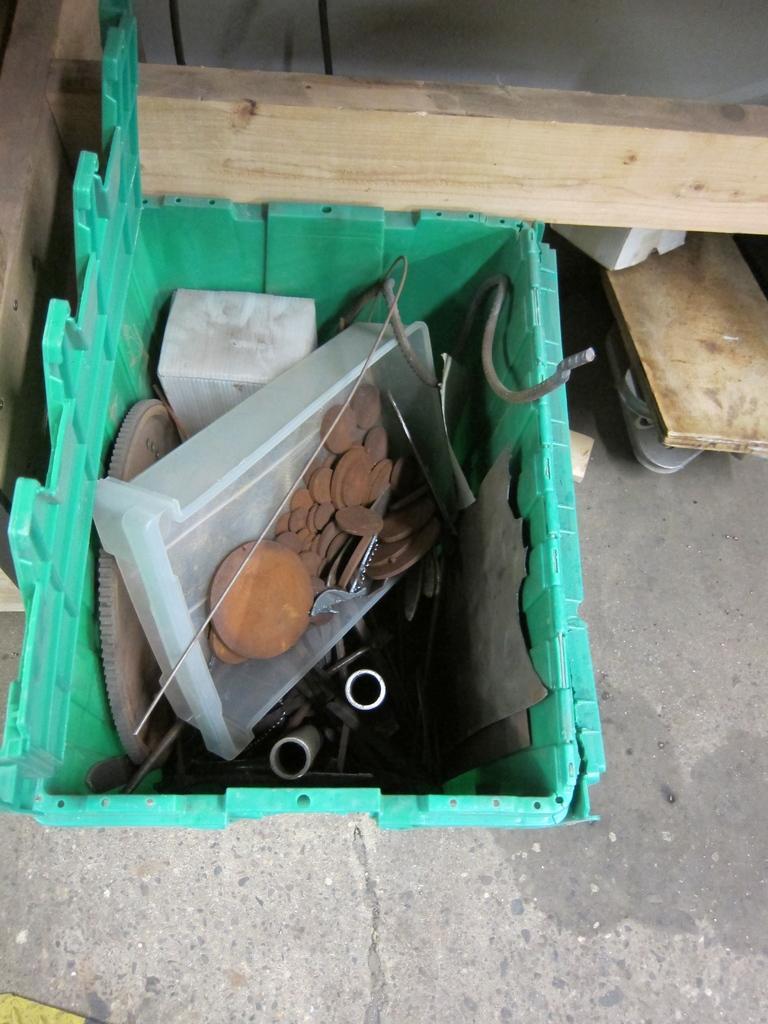Please provide a concise description of this image. At the bottom of the image there is a floor. In the middle of the image there is a basket with a few objects in it and there are a few wooden pieces. 